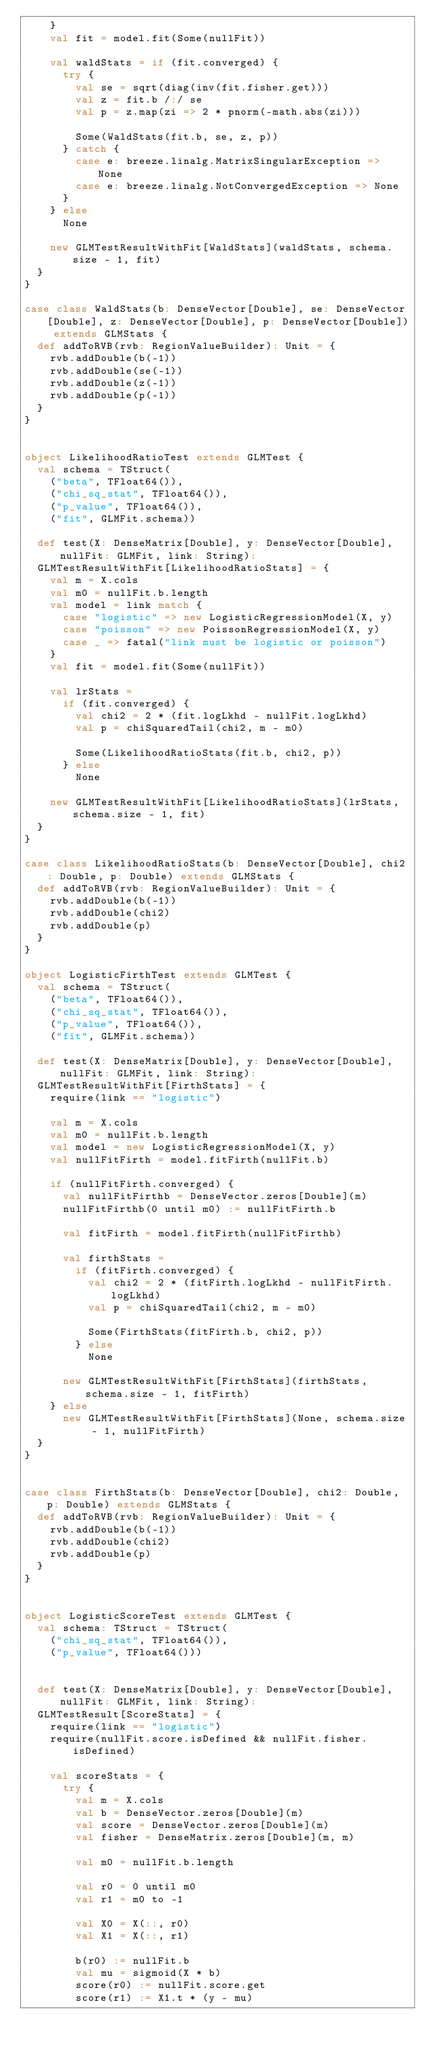<code> <loc_0><loc_0><loc_500><loc_500><_Scala_>    }
    val fit = model.fit(Some(nullFit))

    val waldStats = if (fit.converged) {
      try {
        val se = sqrt(diag(inv(fit.fisher.get)))
        val z = fit.b /:/ se
        val p = z.map(zi => 2 * pnorm(-math.abs(zi)))

        Some(WaldStats(fit.b, se, z, p))
      } catch {
        case e: breeze.linalg.MatrixSingularException => None
        case e: breeze.linalg.NotConvergedException => None
      }
    } else
      None

    new GLMTestResultWithFit[WaldStats](waldStats, schema.size - 1, fit)
  }
}

case class WaldStats(b: DenseVector[Double], se: DenseVector[Double], z: DenseVector[Double], p: DenseVector[Double]) extends GLMStats {
  def addToRVB(rvb: RegionValueBuilder): Unit = {
    rvb.addDouble(b(-1))
    rvb.addDouble(se(-1))
    rvb.addDouble(z(-1))
    rvb.addDouble(p(-1))
  }
}


object LikelihoodRatioTest extends GLMTest {
  val schema = TStruct(
    ("beta", TFloat64()),
    ("chi_sq_stat", TFloat64()),
    ("p_value", TFloat64()),
    ("fit", GLMFit.schema))

  def test(X: DenseMatrix[Double], y: DenseVector[Double], nullFit: GLMFit, link: String):
  GLMTestResultWithFit[LikelihoodRatioStats] = {
    val m = X.cols
    val m0 = nullFit.b.length
    val model = link match {
      case "logistic" => new LogisticRegressionModel(X, y)
      case "poisson" => new PoissonRegressionModel(X, y)
      case _ => fatal("link must be logistic or poisson")
    }
    val fit = model.fit(Some(nullFit))

    val lrStats =
      if (fit.converged) {
        val chi2 = 2 * (fit.logLkhd - nullFit.logLkhd)
        val p = chiSquaredTail(chi2, m - m0)

        Some(LikelihoodRatioStats(fit.b, chi2, p))
      } else
        None

    new GLMTestResultWithFit[LikelihoodRatioStats](lrStats, schema.size - 1, fit)
  }
}

case class LikelihoodRatioStats(b: DenseVector[Double], chi2: Double, p: Double) extends GLMStats {
  def addToRVB(rvb: RegionValueBuilder): Unit = {
    rvb.addDouble(b(-1))
    rvb.addDouble(chi2)
    rvb.addDouble(p)
  }
}

object LogisticFirthTest extends GLMTest {
  val schema = TStruct(
    ("beta", TFloat64()),
    ("chi_sq_stat", TFloat64()),
    ("p_value", TFloat64()),
    ("fit", GLMFit.schema))

  def test(X: DenseMatrix[Double], y: DenseVector[Double], nullFit: GLMFit, link: String):
  GLMTestResultWithFit[FirthStats] = {
    require(link == "logistic")

    val m = X.cols
    val m0 = nullFit.b.length
    val model = new LogisticRegressionModel(X, y)
    val nullFitFirth = model.fitFirth(nullFit.b)

    if (nullFitFirth.converged) {
      val nullFitFirthb = DenseVector.zeros[Double](m)
      nullFitFirthb(0 until m0) := nullFitFirth.b

      val fitFirth = model.fitFirth(nullFitFirthb)

      val firthStats =
        if (fitFirth.converged) {
          val chi2 = 2 * (fitFirth.logLkhd - nullFitFirth.logLkhd)
          val p = chiSquaredTail(chi2, m - m0)

          Some(FirthStats(fitFirth.b, chi2, p))
        } else
          None

      new GLMTestResultWithFit[FirthStats](firthStats, schema.size - 1, fitFirth)
    } else
      new GLMTestResultWithFit[FirthStats](None, schema.size - 1, nullFitFirth)
  }
}


case class FirthStats(b: DenseVector[Double], chi2: Double, p: Double) extends GLMStats {
  def addToRVB(rvb: RegionValueBuilder): Unit = {
    rvb.addDouble(b(-1))
    rvb.addDouble(chi2)
    rvb.addDouble(p)
  }
}


object LogisticScoreTest extends GLMTest {
  val schema: TStruct = TStruct(
    ("chi_sq_stat", TFloat64()),
    ("p_value", TFloat64()))


  def test(X: DenseMatrix[Double], y: DenseVector[Double], nullFit: GLMFit, link: String):
  GLMTestResult[ScoreStats] = {
    require(link == "logistic")
    require(nullFit.score.isDefined && nullFit.fisher.isDefined)

    val scoreStats = {
      try {
        val m = X.cols
        val b = DenseVector.zeros[Double](m)
        val score = DenseVector.zeros[Double](m)
        val fisher = DenseMatrix.zeros[Double](m, m)

        val m0 = nullFit.b.length

        val r0 = 0 until m0
        val r1 = m0 to -1

        val X0 = X(::, r0)
        val X1 = X(::, r1)

        b(r0) := nullFit.b
        val mu = sigmoid(X * b)
        score(r0) := nullFit.score.get
        score(r1) := X1.t * (y - mu)</code> 